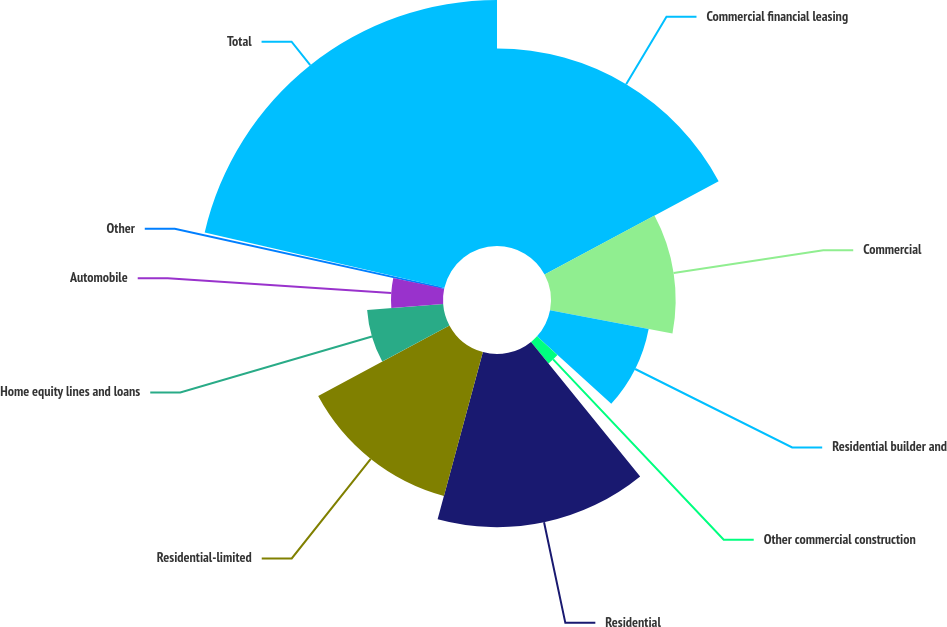<chart> <loc_0><loc_0><loc_500><loc_500><pie_chart><fcel>Commercial financial leasing<fcel>Commercial<fcel>Residential builder and<fcel>Other commercial construction<fcel>Residential<fcel>Residential-limited<fcel>Home equity lines and loans<fcel>Automobile<fcel>Other<fcel>Total<nl><fcel>17.17%<fcel>10.84%<fcel>8.73%<fcel>2.41%<fcel>15.06%<fcel>12.95%<fcel>6.63%<fcel>4.52%<fcel>0.3%<fcel>21.39%<nl></chart> 